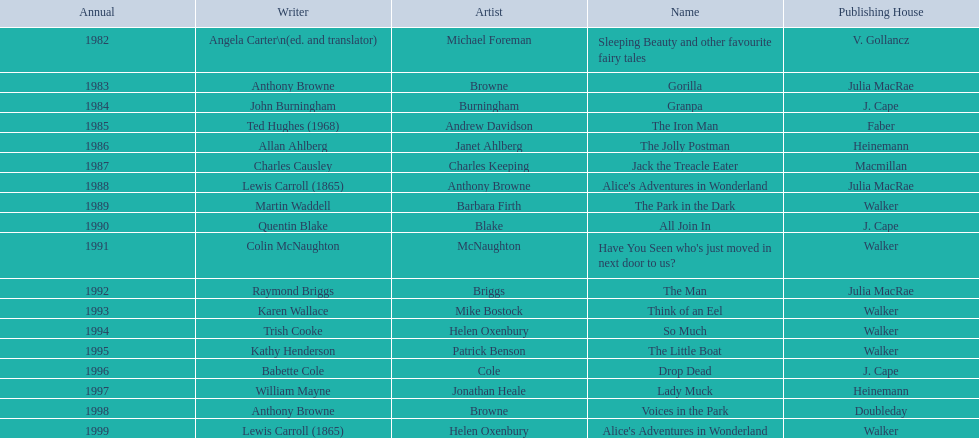How many titles did walker publish? 6. 